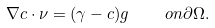Convert formula to latex. <formula><loc_0><loc_0><loc_500><loc_500>\nabla c \cdot \nu = ( \gamma - c ) g \quad o n \partial \Omega .</formula> 